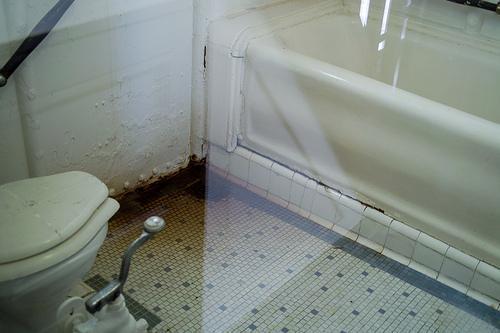How many toilets are there?
Give a very brief answer. 1. 